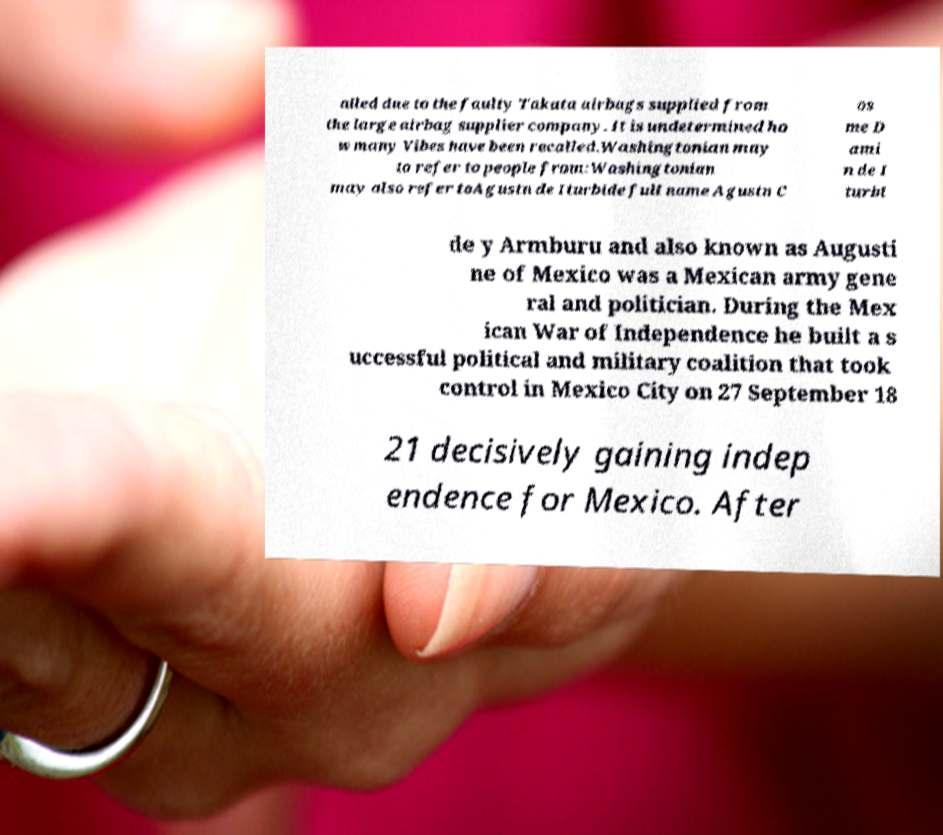Can you read and provide the text displayed in the image?This photo seems to have some interesting text. Can you extract and type it out for me? alled due to the faulty Takata airbags supplied from the large airbag supplier company. It is undetermined ho w many Vibes have been recalled.Washingtonian may to refer to people from:Washingtonian may also refer toAgustn de Iturbide full name Agustn C os me D ami n de I turbi de y Armburu and also known as Augusti ne of Mexico was a Mexican army gene ral and politician. During the Mex ican War of Independence he built a s uccessful political and military coalition that took control in Mexico City on 27 September 18 21 decisively gaining indep endence for Mexico. After 